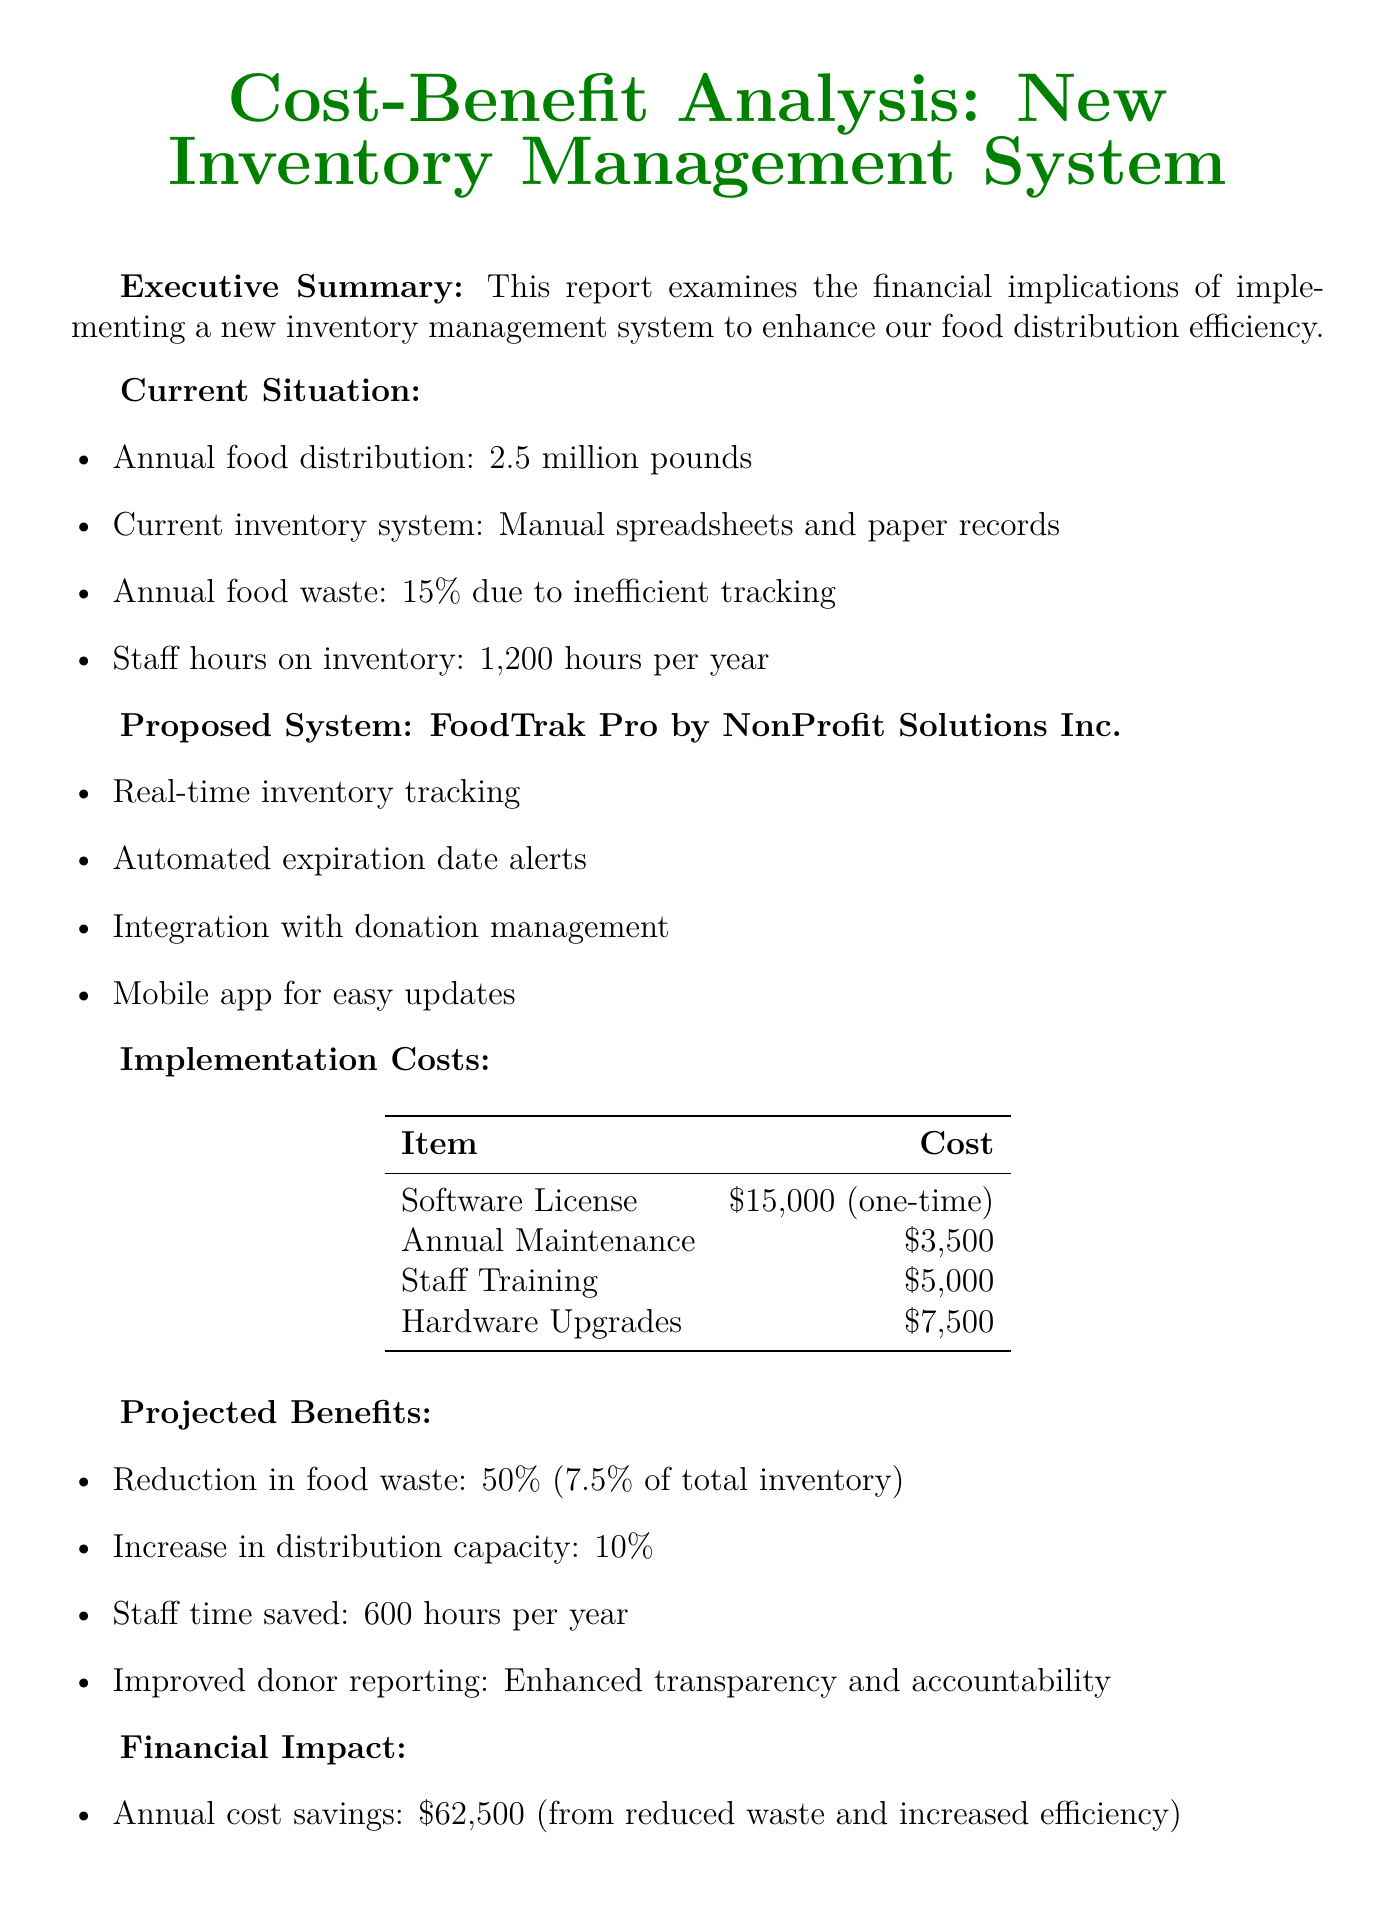What is the annual food distribution for the organization? The annual food distribution is mentioned in the "Current Situation" section, which states that it is 2.5 million pounds.
Answer: 2.5 million pounds What is the annual food waste percentage? The report indicates that the annual food waste is 15% due to inefficient tracking, as stated in the "Current Situation" section.
Answer: 15% What is the name of the proposed inventory management system? The proposed system is listed under the "Proposed System" section, where it is identified as FoodTrak Pro.
Answer: FoodTrak Pro How much staff time is saved annually after implementing the new system? The "Projected Benefits" section details that staff time saved will be 600 hours per year after implementing the new system.
Answer: 600 hours What is the return on investment in the first year? The "Financial Impact" section specifies that the return on investment will be 185% in the first year.
Answer: 185% How long is the payback period for the new system? The document indicates the payback period in the "Financial Impact" section, which is stated to be 7 months.
Answer: 7 months What percentage reduction in food waste is projected? The reduction in food waste is outlined in the "Projected Benefits" section, where it mentions a 50% reduction.
Answer: 50% What is one non-financial benefit listed in the report? The "Non-Financial Benefits" section lists multiple benefits; one of them is "Improved service to food-insecure individuals."
Answer: Improved service to food-insecure individuals How much will be spent on staff training for the new system? This cost is detailed in the "Implementation Costs" section, where staff training is stated to cost $5,000.
Answer: $5,000 